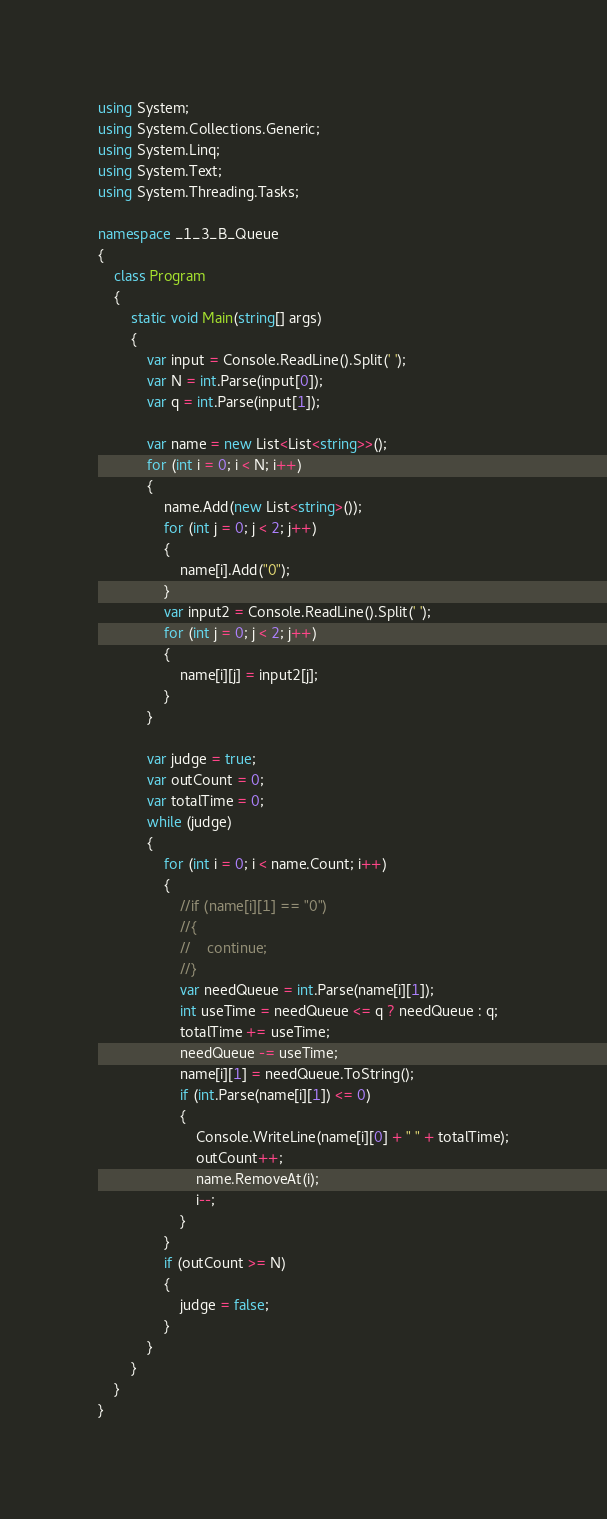<code> <loc_0><loc_0><loc_500><loc_500><_C#_>using System;
using System.Collections.Generic;
using System.Linq;
using System.Text;
using System.Threading.Tasks;

namespace _1_3_B_Queue
{
    class Program
    {
        static void Main(string[] args)
        {
            var input = Console.ReadLine().Split(' ');
            var N = int.Parse(input[0]);
            var q = int.Parse(input[1]);

            var name = new List<List<string>>();
            for (int i = 0; i < N; i++)
            {
                name.Add(new List<string>());
                for (int j = 0; j < 2; j++)
                {
                    name[i].Add("0");
                }
                var input2 = Console.ReadLine().Split(' ');
                for (int j = 0; j < 2; j++)
                {
                    name[i][j] = input2[j];
                }
            }

            var judge = true;
            var outCount = 0;
            var totalTime = 0;
            while (judge)
            {
                for (int i = 0; i < name.Count; i++)
                {
                    //if (name[i][1] == "0")
                    //{
                    //    continue;
                    //}
                    var needQueue = int.Parse(name[i][1]);
                    int useTime = needQueue <= q ? needQueue : q;
                    totalTime += useTime;
                    needQueue -= useTime;
                    name[i][1] = needQueue.ToString();
                    if (int.Parse(name[i][1]) <= 0)
                    {
                        Console.WriteLine(name[i][0] + " " + totalTime);
                        outCount++;
                        name.RemoveAt(i);
                        i--;
                    }
                }
                if (outCount >= N)
                {
                    judge = false;
                }
            }
        }
    }
}

</code> 